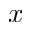Convert formula to latex. <formula><loc_0><loc_0><loc_500><loc_500>x</formula> 